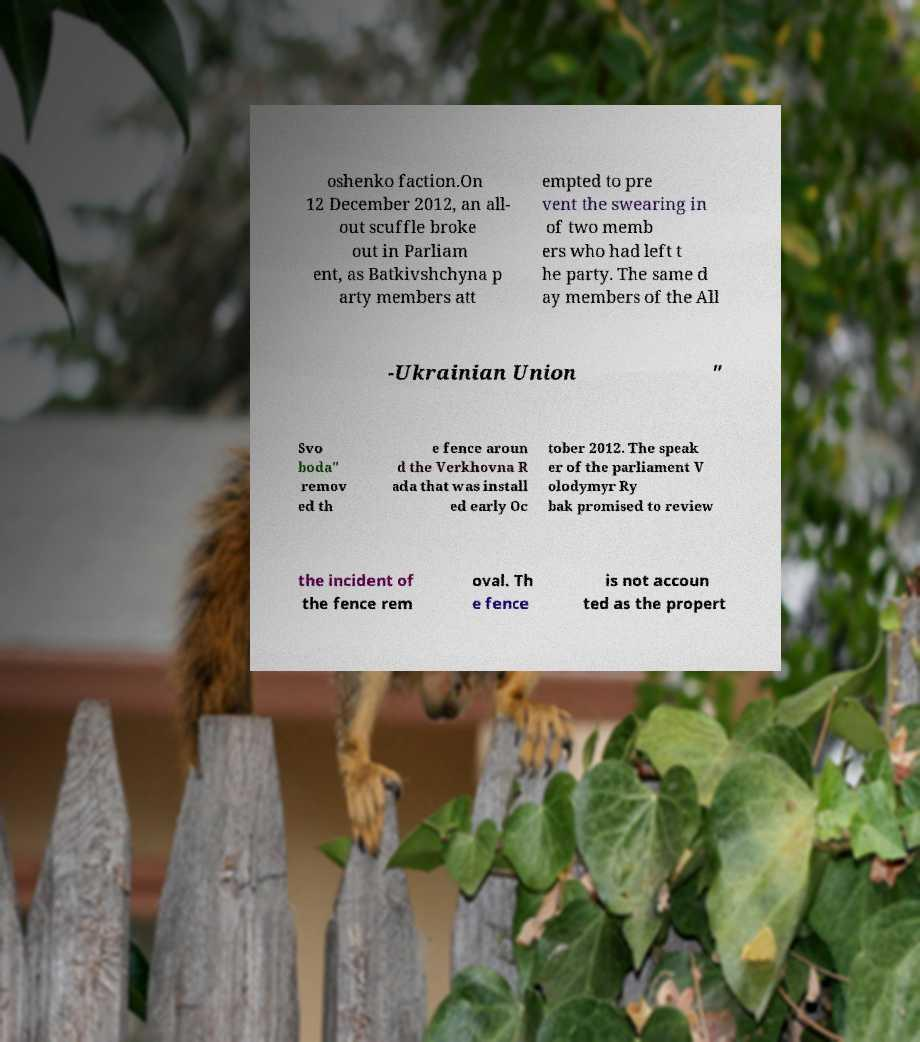For documentation purposes, I need the text within this image transcribed. Could you provide that? oshenko faction.On 12 December 2012, an all- out scuffle broke out in Parliam ent, as Batkivshchyna p arty members att empted to pre vent the swearing in of two memb ers who had left t he party. The same d ay members of the All -Ukrainian Union " Svo boda" remov ed th e fence aroun d the Verkhovna R ada that was install ed early Oc tober 2012. The speak er of the parliament V olodymyr Ry bak promised to review the incident of the fence rem oval. Th e fence is not accoun ted as the propert 